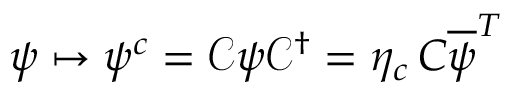<formula> <loc_0><loc_0><loc_500><loc_500>\psi \mapsto \psi ^ { c } = { \mathcal { C } } \psi { \mathcal { C } } ^ { \dagger } = \eta _ { c } \, C { \overline { \psi } } ^ { T }</formula> 